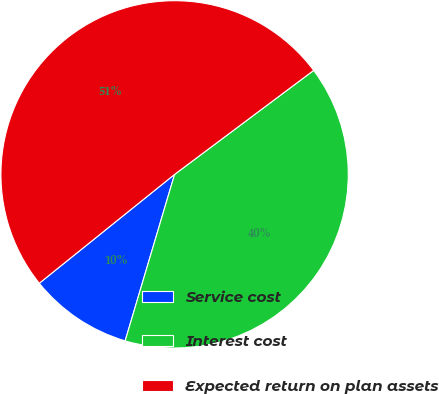Convert chart to OTSL. <chart><loc_0><loc_0><loc_500><loc_500><pie_chart><fcel>Service cost<fcel>Interest cost<fcel>Expected return on plan assets<nl><fcel>9.62%<fcel>39.81%<fcel>50.56%<nl></chart> 